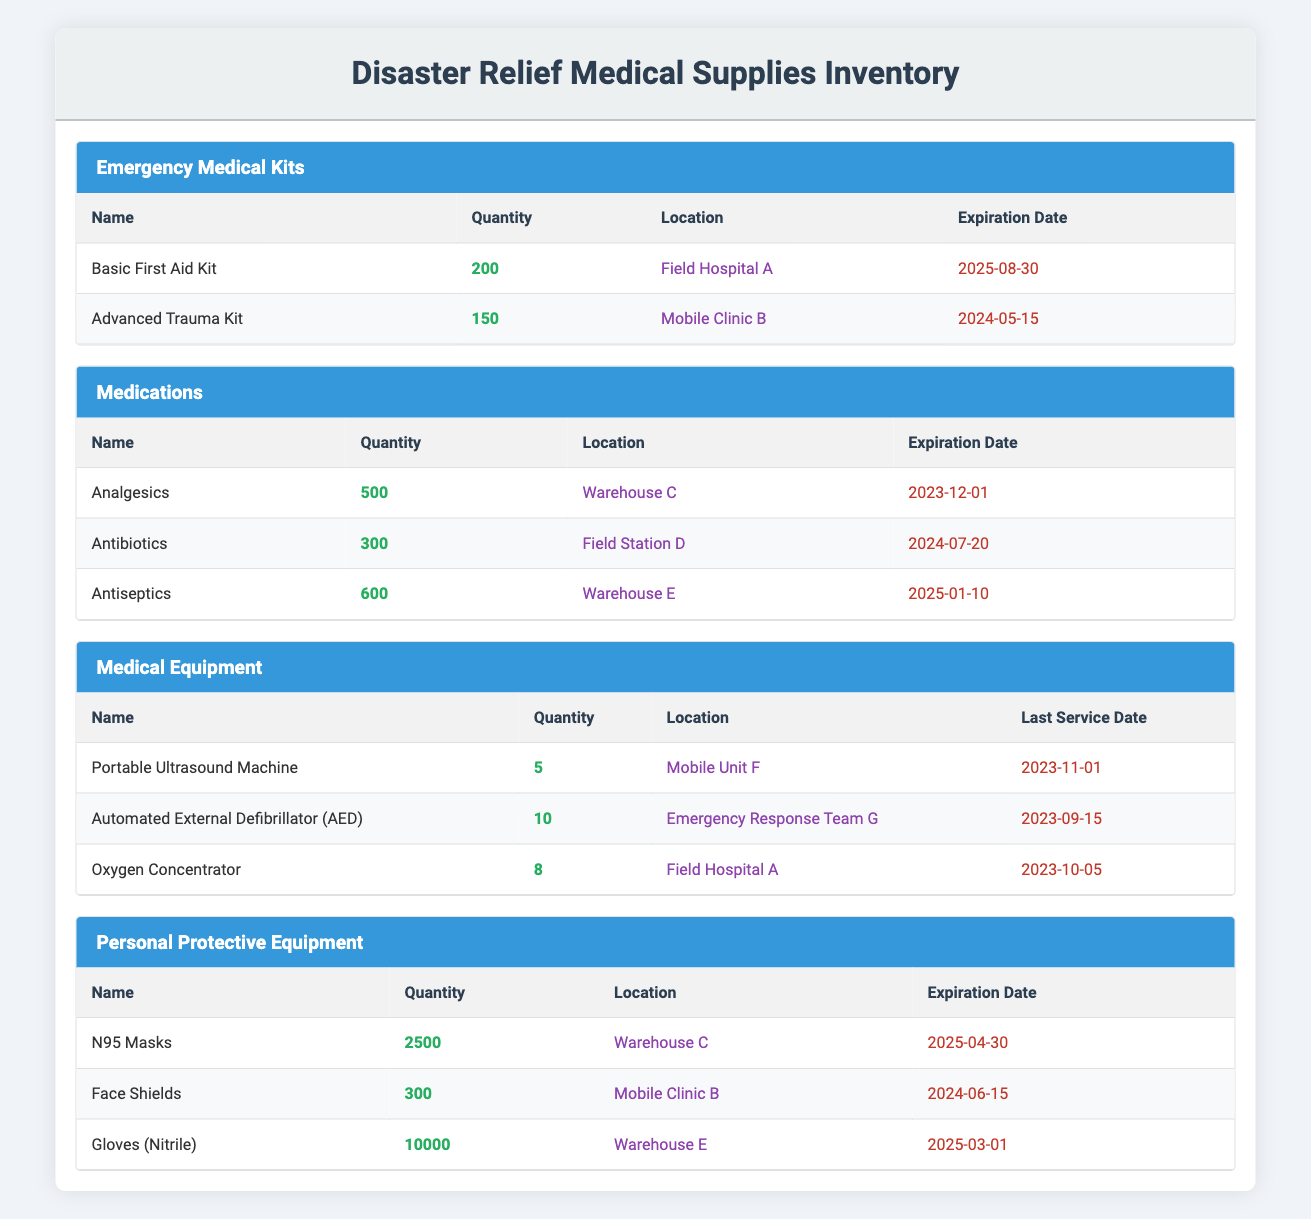What is the total quantity of medications listed? The quantities of the listed medications are: 500 (Analgesics), 300 (Antibiotics), and 600 (Antiseptics). Adding these together: 500 + 300 + 600 = 1400.
Answer: 1400 Where are the N95 Masks stored? The table specifies that N95 Masks are located in Warehouse C.
Answer: Warehouse C Is there an Advanced Trauma Kit in Field Hospital A? Upon checking the table, the Advanced Trauma Kit is stored in Mobile Clinic B, not in Field Hospital A.
Answer: No What is the expiration date for the gloves (nitrile)? The table shows that the expiration date for gloves (nitrile) is 2025-03-01.
Answer: 2025-03-01 How many more gloves (nitrile) are available compared to face shields? There are 10,000 gloves (nitrile) and 300 face shields. The difference can be calculated: 10,000 - 300 = 9,700.
Answer: 9,700 What is the total number of emergency medical kits available? There are two types of emergency medical kits: 200 Basic First Aid Kits and 150 Advanced Trauma Kits. To find the total: 200 + 150 = 350.
Answer: 350 Has the Portable Ultrasound Machine been serviced recently? The last service date for the Portable Ultrasound Machine is given as 2023-11-01, which indicates that it has been serviced recently.
Answer: Yes Which medical equipment has the least quantity? The table lists the Portable Ultrasound Machine (5), Automated External Defibrillator (10), and Oxygen Concentrator (8). The least quantity is for the Portable Ultrasound Machine with 5 units.
Answer: Portable Ultrasound Machine What is the total quantity of Personal Protective Equipment available? The quantities of Personal Protective Equipment are: 2500 (N95 Masks), 300 (Face Shields), and 10,000 (Gloves). Adding these together gives: 2500 + 300 + 10,000 = 12,800.
Answer: 12,800 